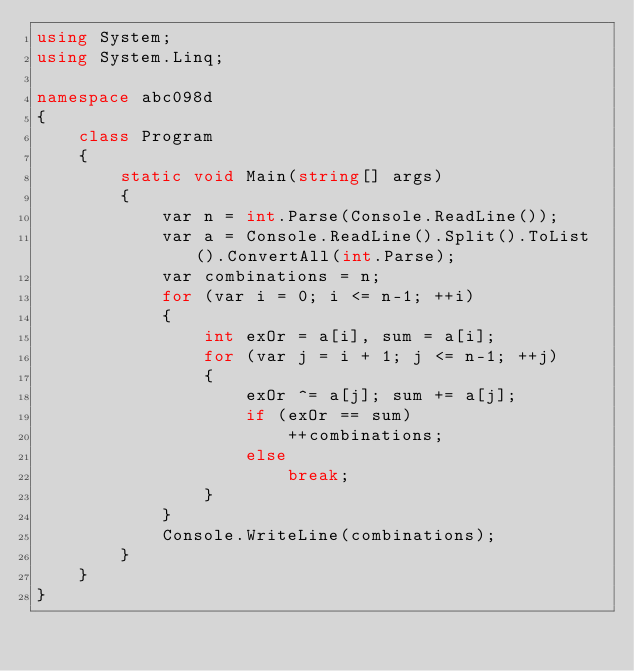<code> <loc_0><loc_0><loc_500><loc_500><_C#_>using System;
using System.Linq;

namespace abc098d
{
    class Program
    {
        static void Main(string[] args)
        {
            var n = int.Parse(Console.ReadLine());
            var a = Console.ReadLine().Split().ToList().ConvertAll(int.Parse);
            var combinations = n;
            for (var i = 0; i <= n-1; ++i)
            {
                int exOr = a[i], sum = a[i];
                for (var j = i + 1; j <= n-1; ++j)
                {
                    exOr ^= a[j]; sum += a[j];
                    if (exOr == sum)
                        ++combinations;
                    else
                        break;
                }
            }
            Console.WriteLine(combinations);
        }
    }
}
</code> 